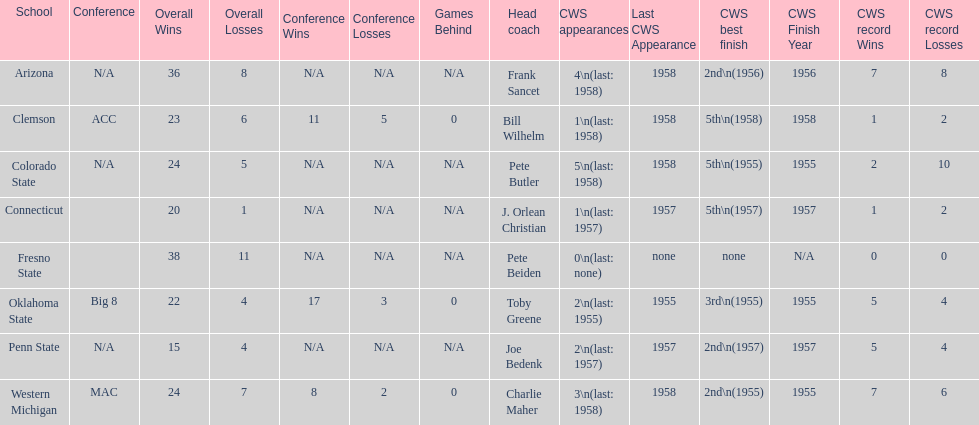Oklahoma state and penn state both have how many cws appearances? 2. 